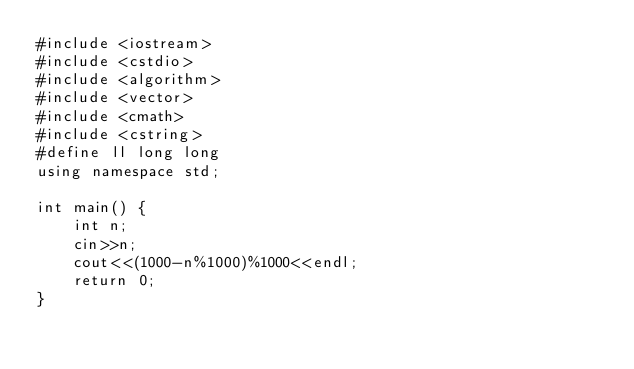<code> <loc_0><loc_0><loc_500><loc_500><_C++_>#include <iostream>
#include <cstdio>
#include <algorithm>
#include <vector>
#include <cmath>
#include <cstring>
#define ll long long
using namespace std;

int main() {
    int n;
    cin>>n;
    cout<<(1000-n%1000)%1000<<endl;
    return 0;
}
</code> 